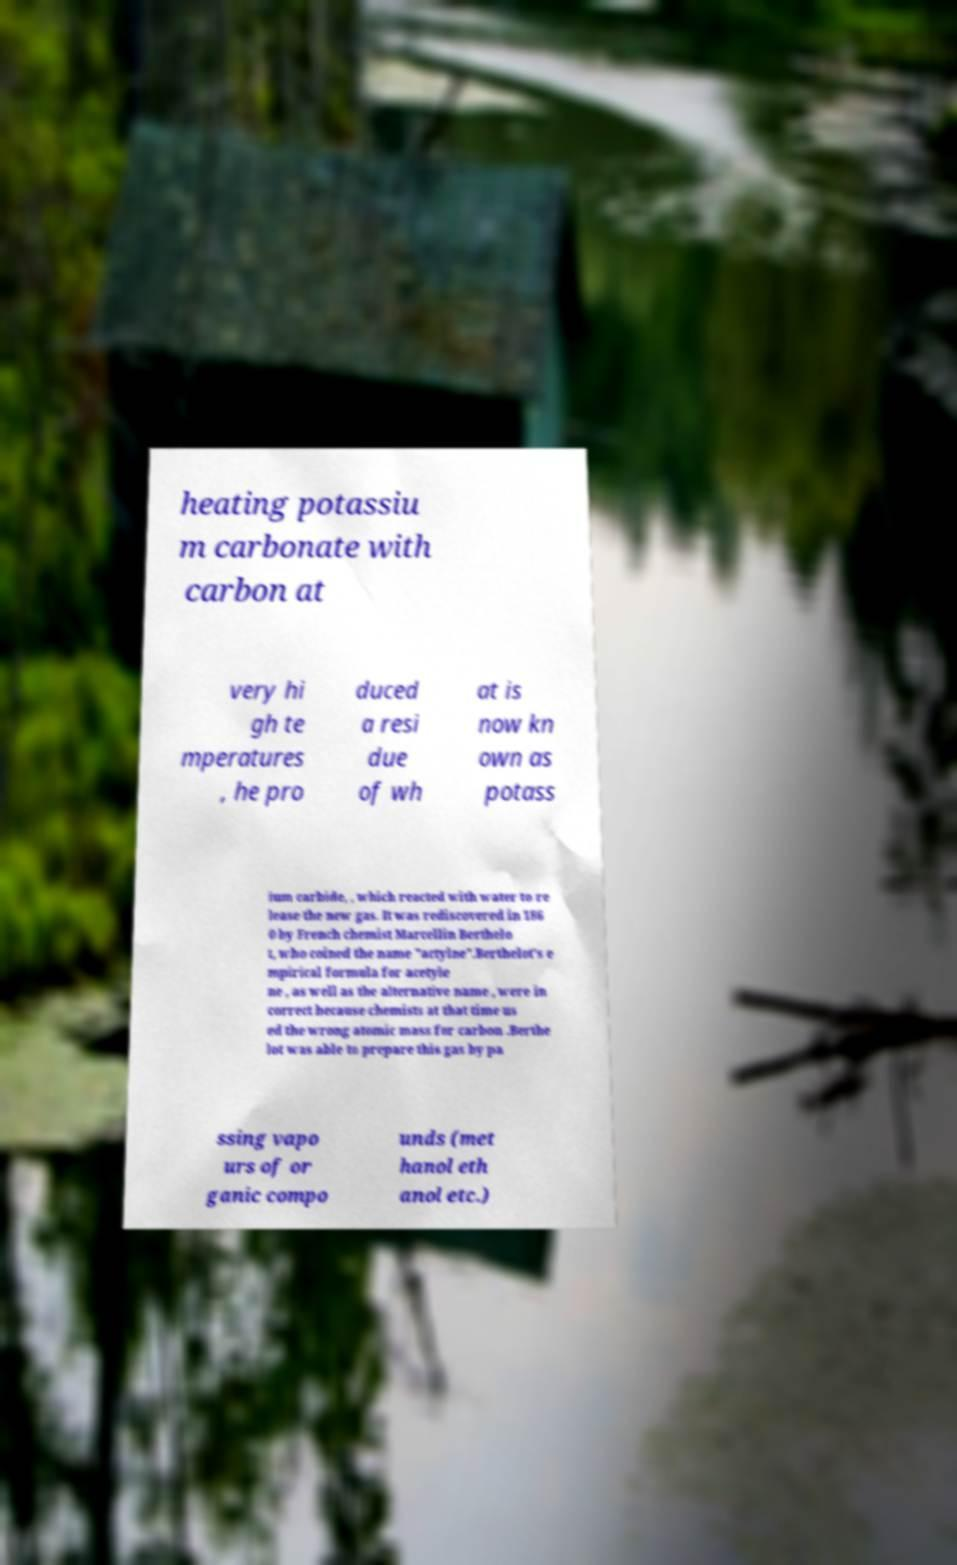I need the written content from this picture converted into text. Can you do that? heating potassiu m carbonate with carbon at very hi gh te mperatures , he pro duced a resi due of wh at is now kn own as potass ium carbide, , which reacted with water to re lease the new gas. It was rediscovered in 186 0 by French chemist Marcellin Berthelo t, who coined the name "actylne".Berthelot's e mpirical formula for acetyle ne , as well as the alternative name , were in correct because chemists at that time us ed the wrong atomic mass for carbon .Berthe lot was able to prepare this gas by pa ssing vapo urs of or ganic compo unds (met hanol eth anol etc.) 